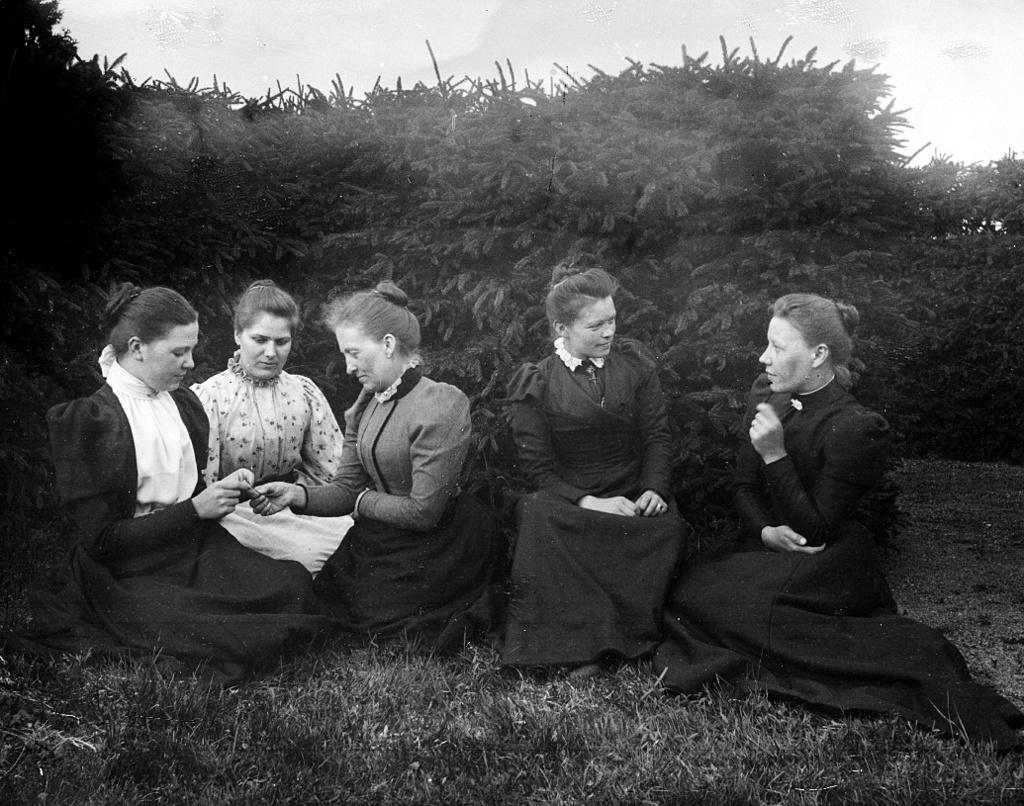How would you summarize this image in a sentence or two? In this image in front there are people sitting on the grass. In the background of the image there are trees and sky. 